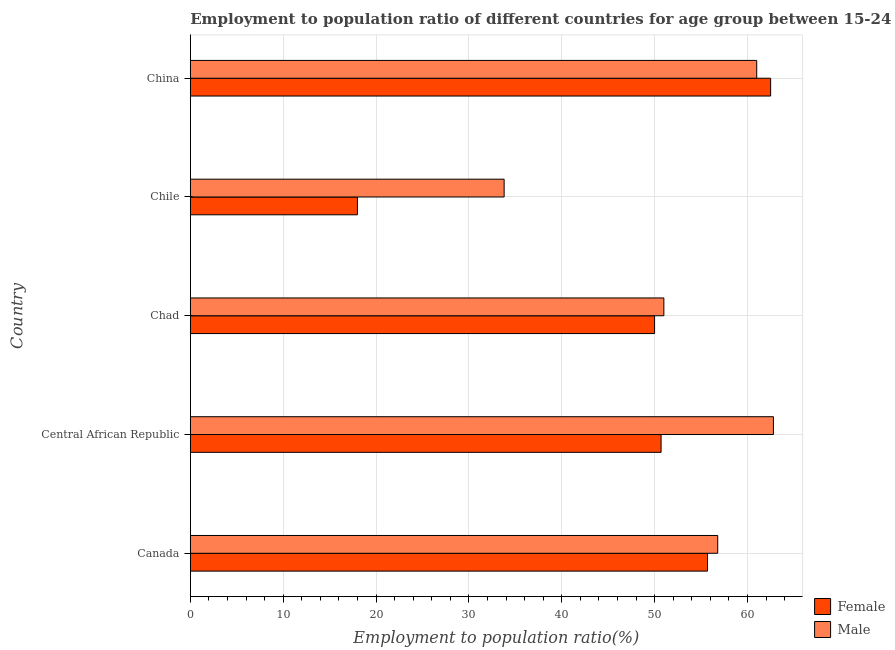How many different coloured bars are there?
Offer a terse response. 2. What is the label of the 2nd group of bars from the top?
Your answer should be very brief. Chile. What is the employment to population ratio(male) in China?
Your answer should be compact. 61. Across all countries, what is the maximum employment to population ratio(female)?
Ensure brevity in your answer.  62.5. Across all countries, what is the minimum employment to population ratio(male)?
Provide a succinct answer. 33.8. In which country was the employment to population ratio(female) minimum?
Keep it short and to the point. Chile. What is the total employment to population ratio(female) in the graph?
Your response must be concise. 236.9. What is the difference between the employment to population ratio(female) in Central African Republic and that in Chad?
Make the answer very short. 0.7. What is the difference between the employment to population ratio(male) in Central African Republic and the employment to population ratio(female) in Chad?
Provide a succinct answer. 12.8. What is the average employment to population ratio(male) per country?
Your answer should be compact. 53.08. What is the difference between the employment to population ratio(female) and employment to population ratio(male) in Chile?
Offer a very short reply. -15.8. What is the difference between the highest and the second highest employment to population ratio(male)?
Keep it short and to the point. 1.8. What is the difference between the highest and the lowest employment to population ratio(male)?
Your answer should be very brief. 29. Is the sum of the employment to population ratio(male) in Chile and China greater than the maximum employment to population ratio(female) across all countries?
Your response must be concise. Yes. What does the 2nd bar from the top in China represents?
Give a very brief answer. Female. What does the 1st bar from the bottom in Central African Republic represents?
Give a very brief answer. Female. How many bars are there?
Offer a very short reply. 10. Where does the legend appear in the graph?
Your response must be concise. Bottom right. How many legend labels are there?
Ensure brevity in your answer.  2. What is the title of the graph?
Offer a terse response. Employment to population ratio of different countries for age group between 15-24 years. Does "Resident workers" appear as one of the legend labels in the graph?
Ensure brevity in your answer.  No. What is the label or title of the X-axis?
Make the answer very short. Employment to population ratio(%). What is the label or title of the Y-axis?
Make the answer very short. Country. What is the Employment to population ratio(%) in Female in Canada?
Offer a very short reply. 55.7. What is the Employment to population ratio(%) of Male in Canada?
Offer a terse response. 56.8. What is the Employment to population ratio(%) in Female in Central African Republic?
Keep it short and to the point. 50.7. What is the Employment to population ratio(%) of Male in Central African Republic?
Offer a very short reply. 62.8. What is the Employment to population ratio(%) in Female in Chad?
Ensure brevity in your answer.  50. What is the Employment to population ratio(%) in Male in Chad?
Provide a short and direct response. 51. What is the Employment to population ratio(%) of Female in Chile?
Offer a terse response. 18. What is the Employment to population ratio(%) in Male in Chile?
Ensure brevity in your answer.  33.8. What is the Employment to population ratio(%) of Female in China?
Give a very brief answer. 62.5. Across all countries, what is the maximum Employment to population ratio(%) of Female?
Offer a terse response. 62.5. Across all countries, what is the maximum Employment to population ratio(%) in Male?
Ensure brevity in your answer.  62.8. Across all countries, what is the minimum Employment to population ratio(%) of Male?
Provide a short and direct response. 33.8. What is the total Employment to population ratio(%) in Female in the graph?
Offer a terse response. 236.9. What is the total Employment to population ratio(%) of Male in the graph?
Give a very brief answer. 265.4. What is the difference between the Employment to population ratio(%) of Male in Canada and that in Central African Republic?
Keep it short and to the point. -6. What is the difference between the Employment to population ratio(%) in Female in Canada and that in Chad?
Your answer should be very brief. 5.7. What is the difference between the Employment to population ratio(%) of Male in Canada and that in Chad?
Provide a succinct answer. 5.8. What is the difference between the Employment to population ratio(%) in Female in Canada and that in Chile?
Ensure brevity in your answer.  37.7. What is the difference between the Employment to population ratio(%) of Female in Canada and that in China?
Offer a very short reply. -6.8. What is the difference between the Employment to population ratio(%) of Male in Central African Republic and that in Chad?
Offer a terse response. 11.8. What is the difference between the Employment to population ratio(%) of Female in Central African Republic and that in Chile?
Keep it short and to the point. 32.7. What is the difference between the Employment to population ratio(%) in Female in Central African Republic and that in China?
Keep it short and to the point. -11.8. What is the difference between the Employment to population ratio(%) in Male in Central African Republic and that in China?
Offer a very short reply. 1.8. What is the difference between the Employment to population ratio(%) in Male in Chad and that in Chile?
Offer a very short reply. 17.2. What is the difference between the Employment to population ratio(%) of Male in Chad and that in China?
Keep it short and to the point. -10. What is the difference between the Employment to population ratio(%) in Female in Chile and that in China?
Keep it short and to the point. -44.5. What is the difference between the Employment to population ratio(%) in Male in Chile and that in China?
Provide a succinct answer. -27.2. What is the difference between the Employment to population ratio(%) in Female in Canada and the Employment to population ratio(%) in Male in Chad?
Offer a terse response. 4.7. What is the difference between the Employment to population ratio(%) in Female in Canada and the Employment to population ratio(%) in Male in Chile?
Your answer should be compact. 21.9. What is the difference between the Employment to population ratio(%) in Female in Canada and the Employment to population ratio(%) in Male in China?
Your answer should be very brief. -5.3. What is the difference between the Employment to population ratio(%) of Female in Central African Republic and the Employment to population ratio(%) of Male in Chad?
Keep it short and to the point. -0.3. What is the difference between the Employment to population ratio(%) in Female in Central African Republic and the Employment to population ratio(%) in Male in Chile?
Offer a terse response. 16.9. What is the difference between the Employment to population ratio(%) in Female in Chad and the Employment to population ratio(%) in Male in Chile?
Your response must be concise. 16.2. What is the difference between the Employment to population ratio(%) of Female in Chile and the Employment to population ratio(%) of Male in China?
Provide a succinct answer. -43. What is the average Employment to population ratio(%) of Female per country?
Your answer should be compact. 47.38. What is the average Employment to population ratio(%) in Male per country?
Ensure brevity in your answer.  53.08. What is the difference between the Employment to population ratio(%) in Female and Employment to population ratio(%) in Male in Canada?
Offer a very short reply. -1.1. What is the difference between the Employment to population ratio(%) in Female and Employment to population ratio(%) in Male in Chad?
Offer a terse response. -1. What is the difference between the Employment to population ratio(%) of Female and Employment to population ratio(%) of Male in Chile?
Provide a succinct answer. -15.8. What is the ratio of the Employment to population ratio(%) in Female in Canada to that in Central African Republic?
Your response must be concise. 1.1. What is the ratio of the Employment to population ratio(%) in Male in Canada to that in Central African Republic?
Ensure brevity in your answer.  0.9. What is the ratio of the Employment to population ratio(%) in Female in Canada to that in Chad?
Your answer should be very brief. 1.11. What is the ratio of the Employment to population ratio(%) of Male in Canada to that in Chad?
Provide a succinct answer. 1.11. What is the ratio of the Employment to population ratio(%) in Female in Canada to that in Chile?
Your answer should be compact. 3.09. What is the ratio of the Employment to population ratio(%) in Male in Canada to that in Chile?
Ensure brevity in your answer.  1.68. What is the ratio of the Employment to population ratio(%) of Female in Canada to that in China?
Offer a terse response. 0.89. What is the ratio of the Employment to population ratio(%) of Male in Canada to that in China?
Your answer should be compact. 0.93. What is the ratio of the Employment to population ratio(%) in Male in Central African Republic to that in Chad?
Ensure brevity in your answer.  1.23. What is the ratio of the Employment to population ratio(%) of Female in Central African Republic to that in Chile?
Keep it short and to the point. 2.82. What is the ratio of the Employment to population ratio(%) of Male in Central African Republic to that in Chile?
Your answer should be compact. 1.86. What is the ratio of the Employment to population ratio(%) of Female in Central African Republic to that in China?
Provide a short and direct response. 0.81. What is the ratio of the Employment to population ratio(%) in Male in Central African Republic to that in China?
Your answer should be very brief. 1.03. What is the ratio of the Employment to population ratio(%) of Female in Chad to that in Chile?
Your answer should be compact. 2.78. What is the ratio of the Employment to population ratio(%) of Male in Chad to that in Chile?
Ensure brevity in your answer.  1.51. What is the ratio of the Employment to population ratio(%) in Female in Chad to that in China?
Provide a succinct answer. 0.8. What is the ratio of the Employment to population ratio(%) of Male in Chad to that in China?
Give a very brief answer. 0.84. What is the ratio of the Employment to population ratio(%) of Female in Chile to that in China?
Provide a succinct answer. 0.29. What is the ratio of the Employment to population ratio(%) in Male in Chile to that in China?
Your response must be concise. 0.55. What is the difference between the highest and the second highest Employment to population ratio(%) of Male?
Provide a succinct answer. 1.8. What is the difference between the highest and the lowest Employment to population ratio(%) in Female?
Keep it short and to the point. 44.5. 